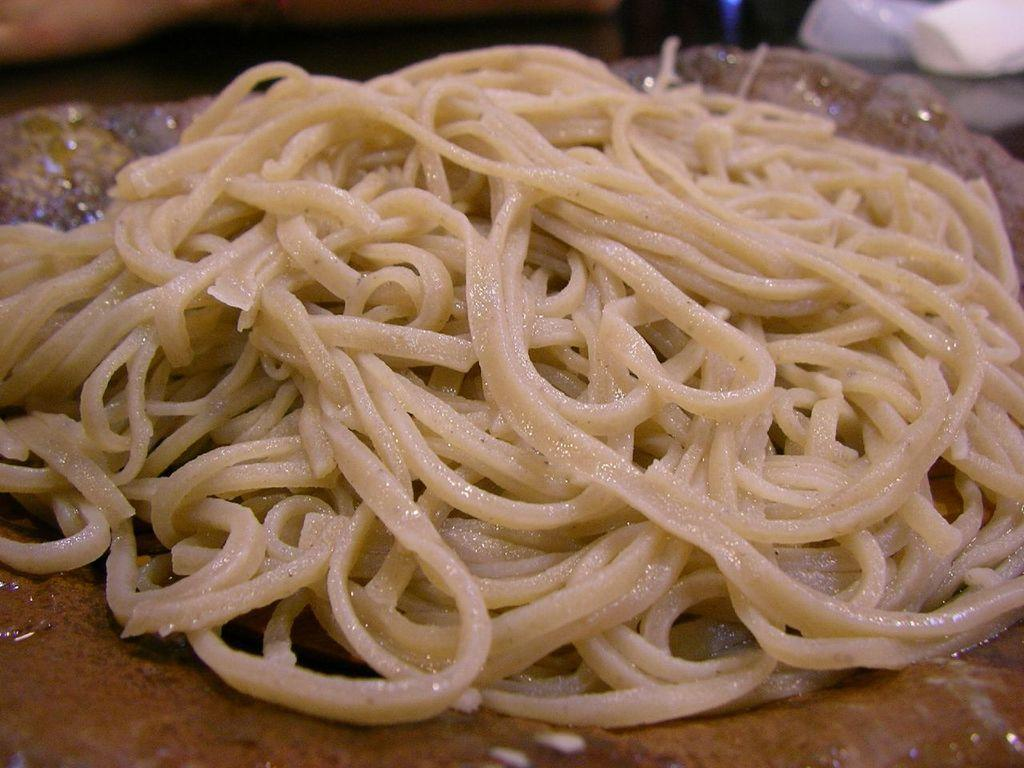What type of food is visible in the image? There are noodles in the image. What is the color of the bottom part of the image? The bottom part of the image is brown in color. What is the color of the top part of the image? The top part of the image is black in color. Can you describe the object in the top right corner of the image? There is an object in white color in the top right corner of the image. What rhythm does the noodle follow as it moves through the image? The noodles do not move through the image, and therefore there is no rhythm to follow. 